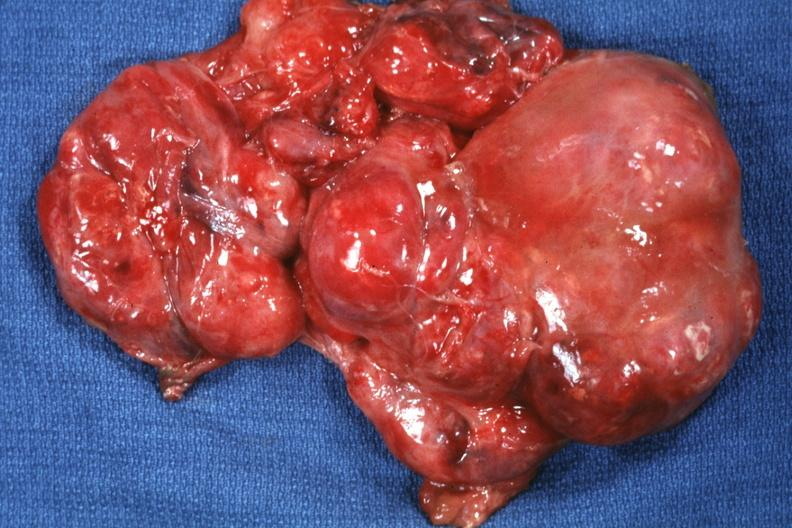s sacrococcygeal teratoma present?
Answer the question using a single word or phrase. Yes 